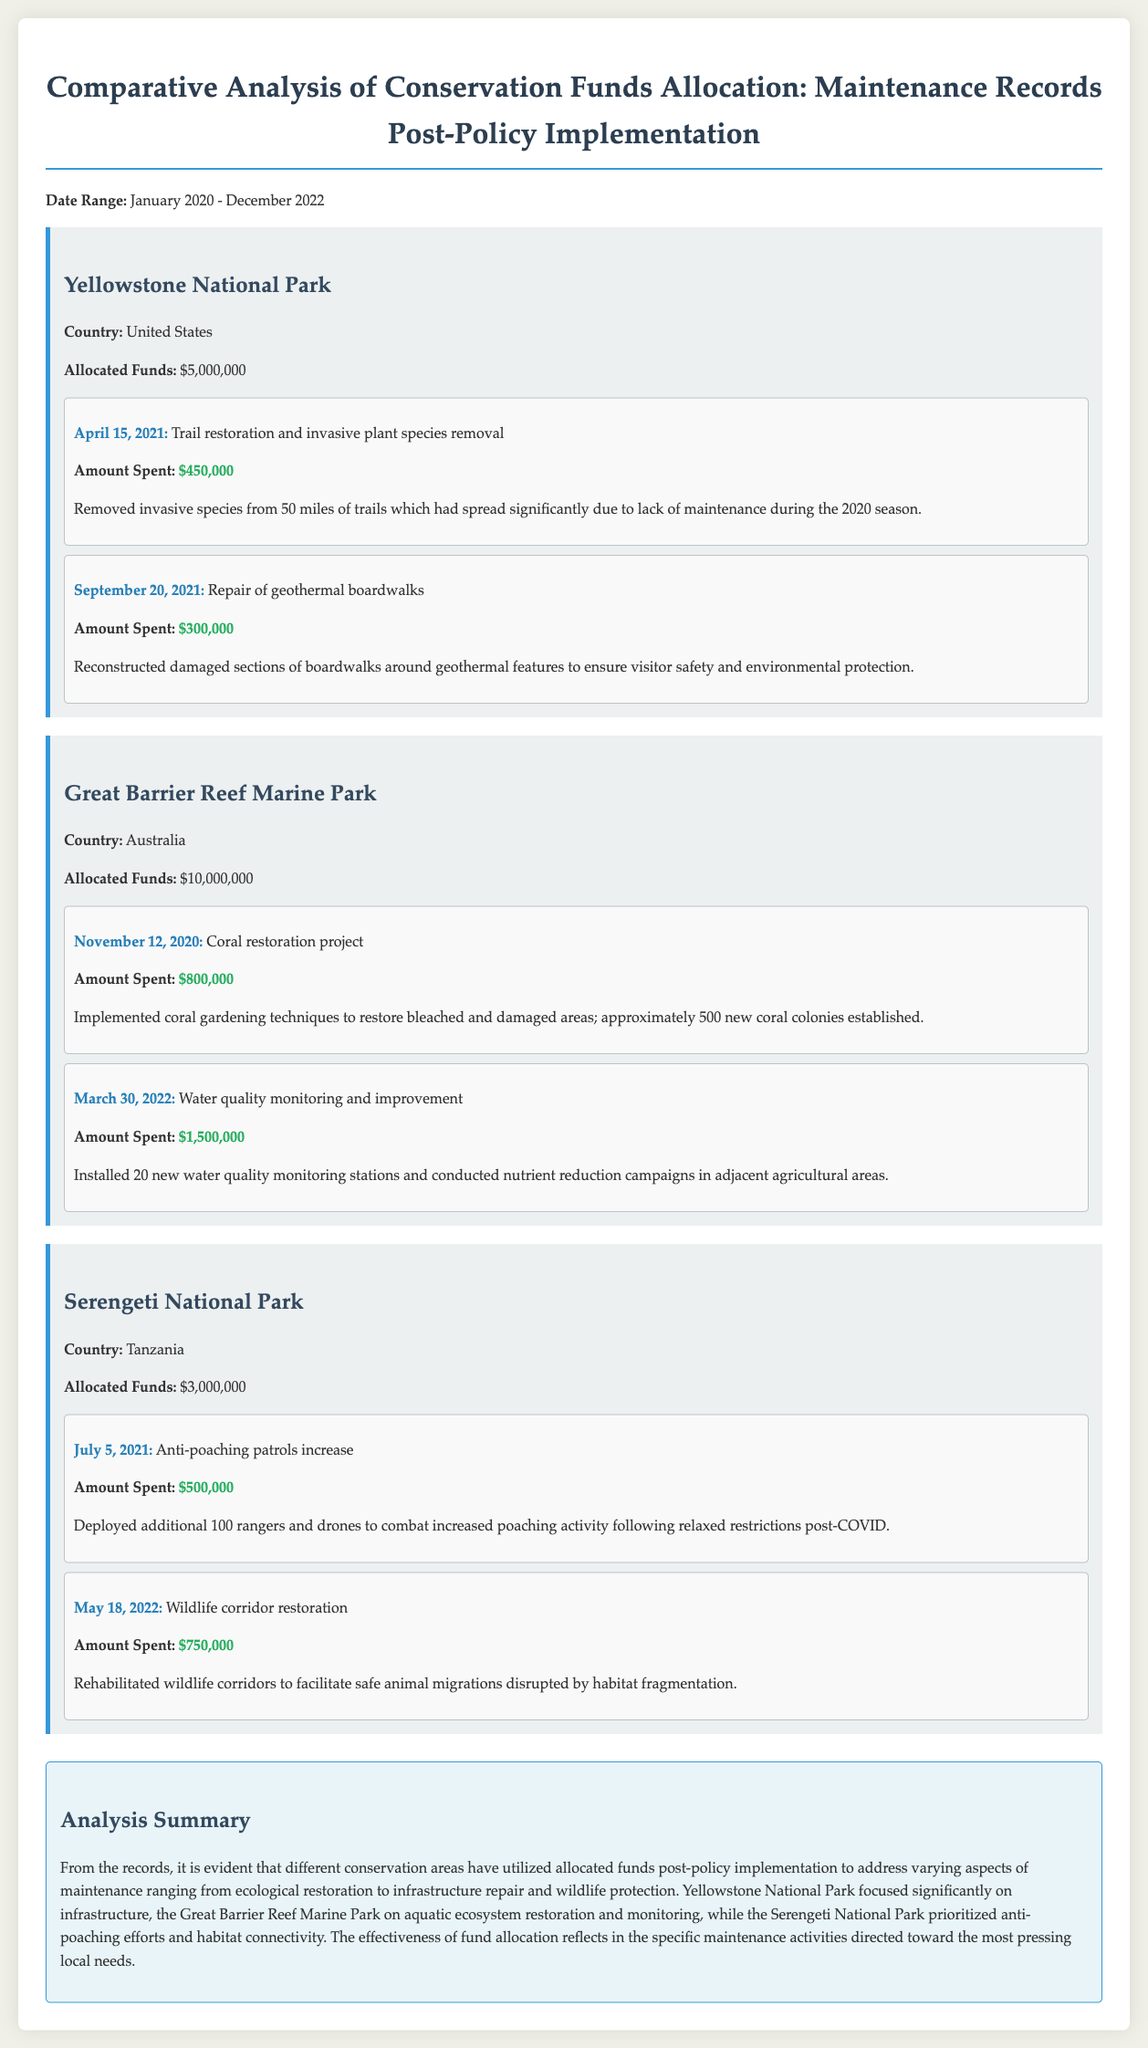What is the allocated fund for Yellowstone National Park? The document states that the allocated funds for Yellowstone National Park are $5,000,000.
Answer: $5,000,000 When was the coral restoration project undertaken in Great Barrier Reef Marine Park? According to the maintenance log, the coral restoration project was conducted on November 12, 2020.
Answer: November 12, 2020 How much was spent on anti-poaching patrols in Serengeti National Park? The document indicates that $500,000 was spent on anti-poaching patrols.
Answer: $500,000 What type of project took place at Great Barrier Reef Marine Park on March 30, 2022? The document describes the maintenance activity on that date as water quality monitoring and improvement.
Answer: Water quality monitoring and improvement Which national park focused on infrastructure improvements post-policy implementation? The maintenance log shows that Yellowstone National Park emphasized infrastructure improvements like trail restoration and boardwalk repairs.
Answer: Yellowstone National Park What was the total allocated fund for Great Barrier Reef Marine Park? The document lists the allocated funds for Great Barrier Reef Marine Park as $10,000,000.
Answer: $10,000,000 What specific activity was highlighted for the date July 5, 2021, in Serengeti National Park? The maintenance record on that date mentions an increase in anti-poaching patrols.
Answer: Anti-poaching patrols increase What was the primary focus of funds allocated to the Great Barrier Reef Marine Park? The summary indicates the focus was on aquatic ecosystem restoration and monitoring.
Answer: Aquatic ecosystem restoration and monitoring How many new rangers were deployed in response to increased poaching activity in Serengeti National Park? The document notes that an additional 100 rangers were deployed.
Answer: 100 rangers 